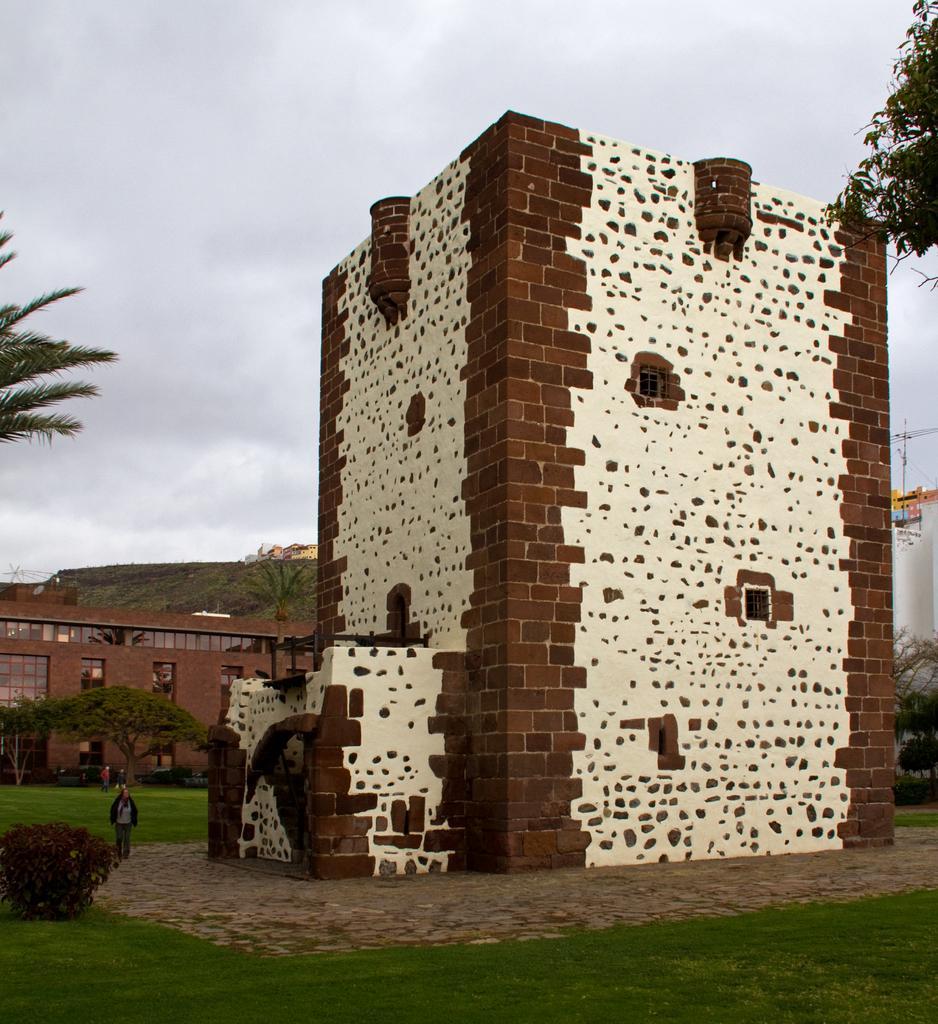Please provide a concise description of this image. In this image we can see a building with windows. We can also see some plants, grass and a person standing beside. On the backside we can see a group of trees, a building, the hills and the sky which looks cloudy. 